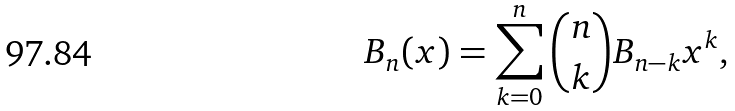<formula> <loc_0><loc_0><loc_500><loc_500>B _ { n } ( x ) = \sum _ { k = 0 } ^ { n } { \binom { n } { k } B _ { n - k } x ^ { k } } ,</formula> 